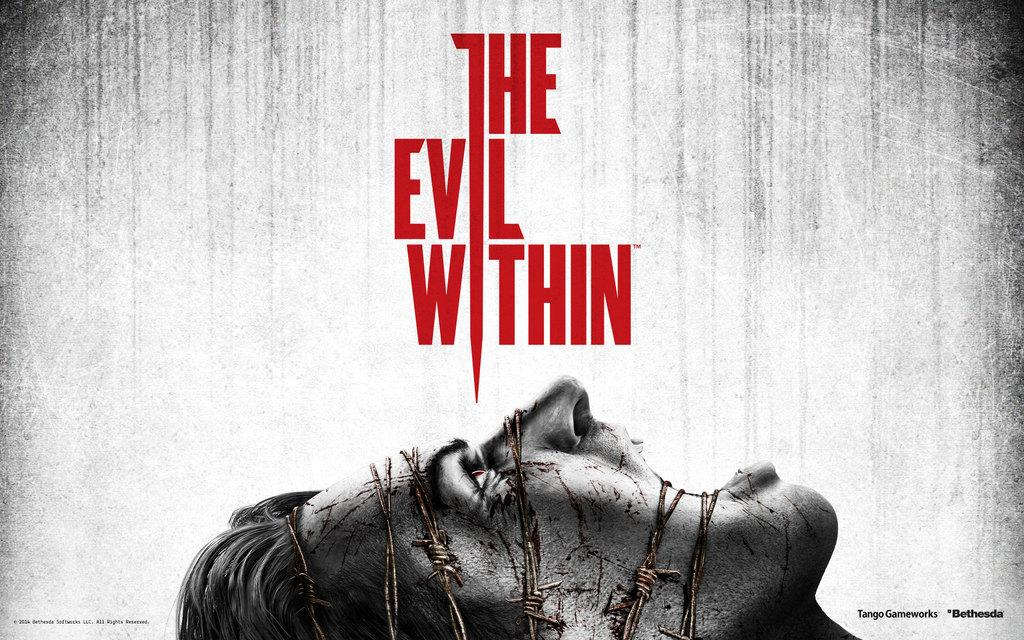What is happening to the person's face in the image? The person's face is tied with metal wire in the image. Are there any words or phrases visible in the image? Yes, there is text written on the image. Where can a watermark be found in the image? The watermark is located at the bottom right side of the image. Can you see any grass growing in the image? There is no grass visible in the image. How many family members are present in the image? There is no family depicted in the image. 